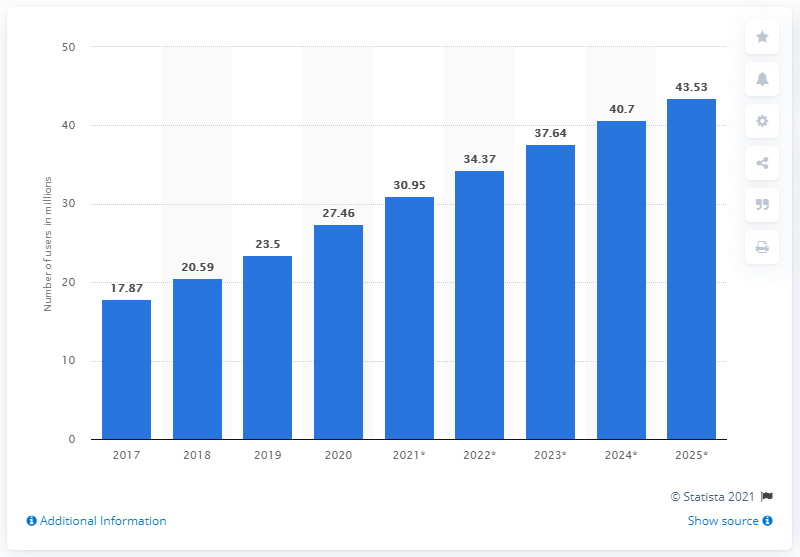Give some essential details in this illustration. According to data from 2020, the Facebook user population in Nigeria was approximately 27.46 million people. The Facebook user population in Nigeria is expected to reach 43.53 million by 2025. 